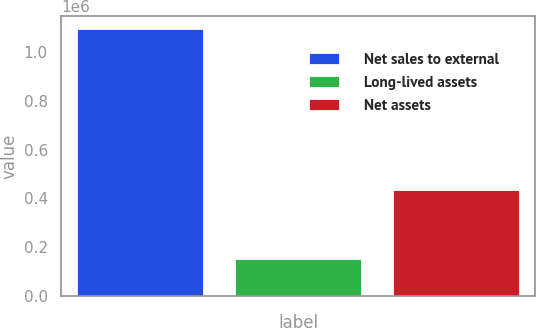Convert chart to OTSL. <chart><loc_0><loc_0><loc_500><loc_500><bar_chart><fcel>Net sales to external<fcel>Long-lived assets<fcel>Net assets<nl><fcel>1.09358e+06<fcel>148922<fcel>431795<nl></chart> 